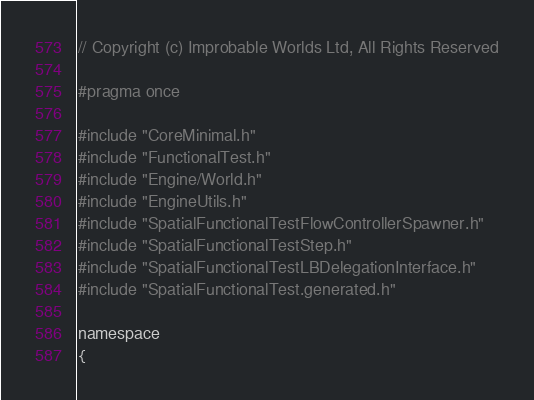Convert code to text. <code><loc_0><loc_0><loc_500><loc_500><_C_>// Copyright (c) Improbable Worlds Ltd, All Rights Reserved

#pragma once

#include "CoreMinimal.h"
#include "FunctionalTest.h"
#include "Engine/World.h"
#include "EngineUtils.h"
#include "SpatialFunctionalTestFlowControllerSpawner.h"
#include "SpatialFunctionalTestStep.h"
#include "SpatialFunctionalTestLBDelegationInterface.h"
#include "SpatialFunctionalTest.generated.h"

namespace 
{</code> 